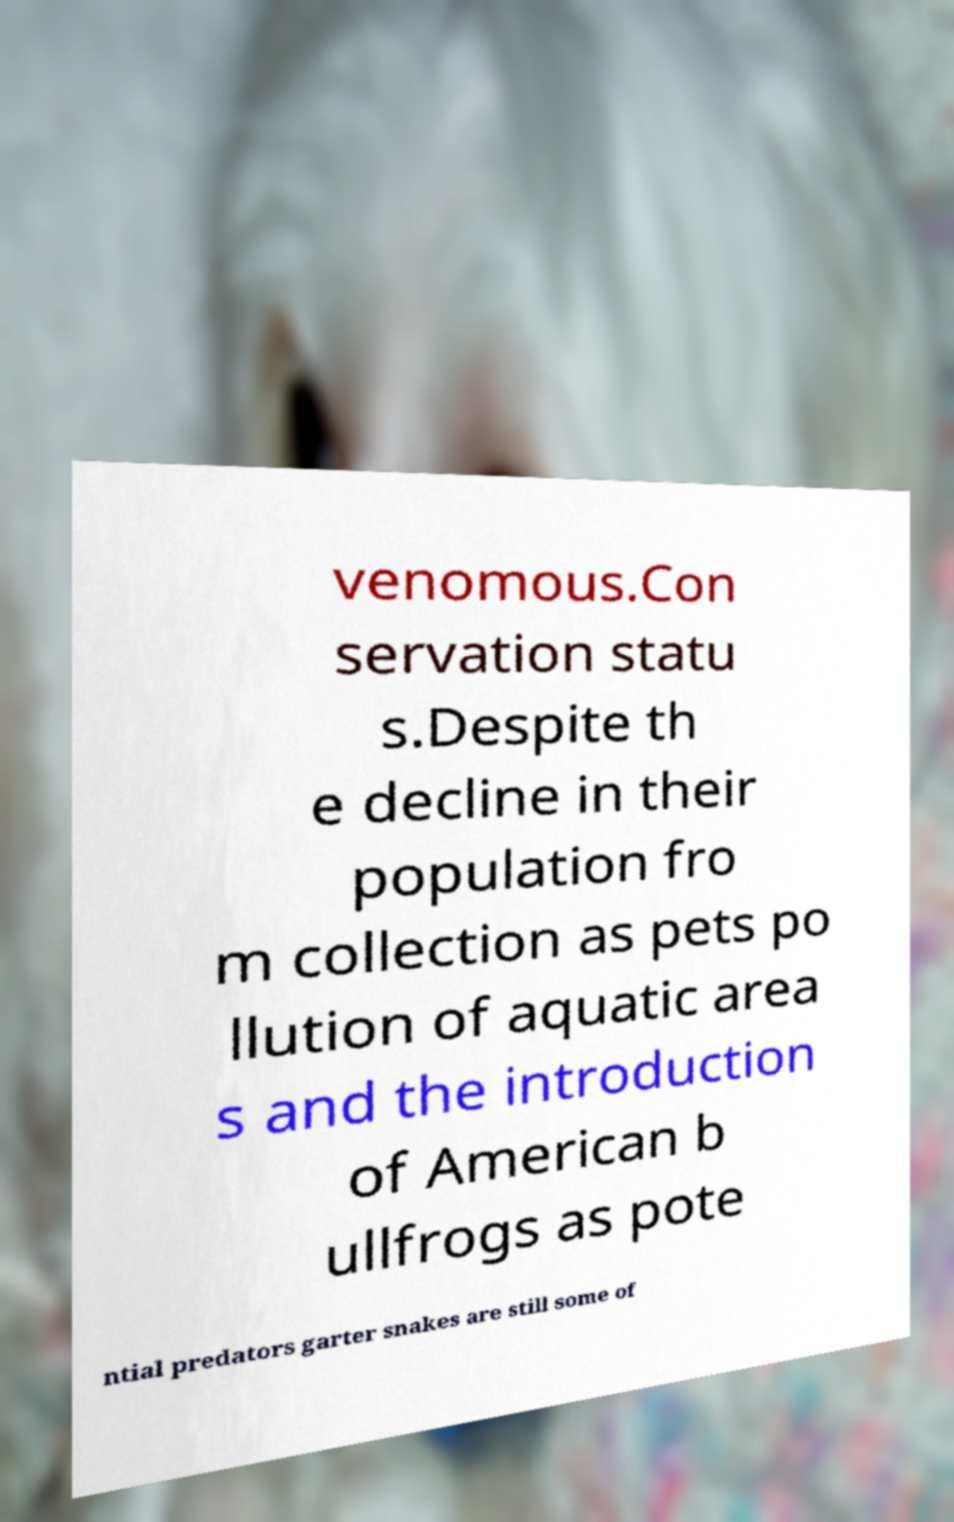Please identify and transcribe the text found in this image. venomous.Con servation statu s.Despite th e decline in their population fro m collection as pets po llution of aquatic area s and the introduction of American b ullfrogs as pote ntial predators garter snakes are still some of 